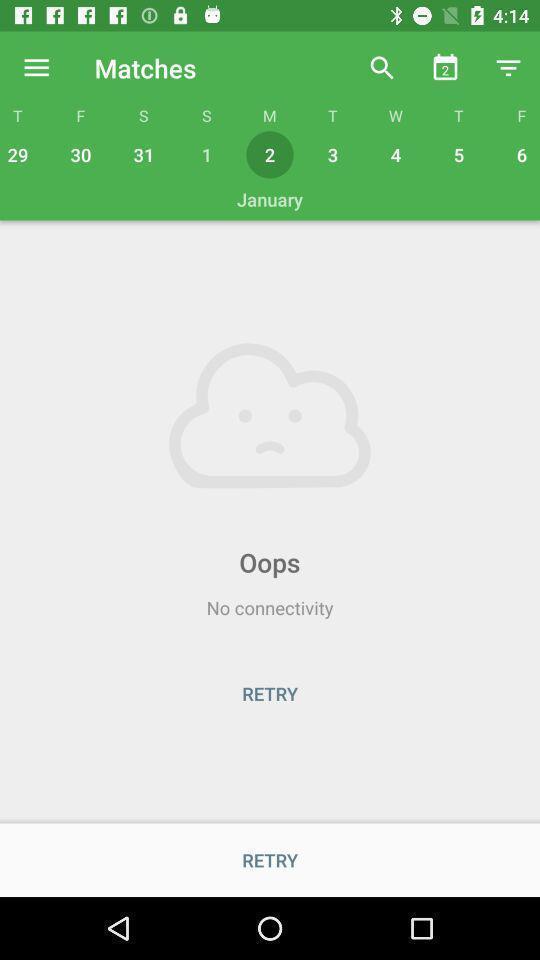What details can you identify in this image? Page showing option like retry. 